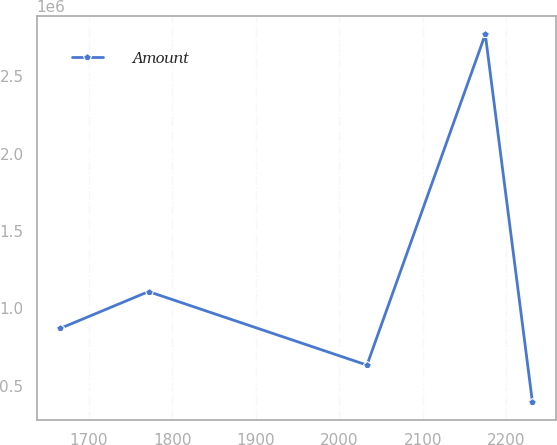<chart> <loc_0><loc_0><loc_500><loc_500><line_chart><ecel><fcel>Amount<nl><fcel>1665.99<fcel>870076<nl><fcel>1771.55<fcel>1.10782e+06<nl><fcel>2033.01<fcel>632330<nl><fcel>2174.67<fcel>2.77204e+06<nl><fcel>2231.07<fcel>394585<nl></chart> 